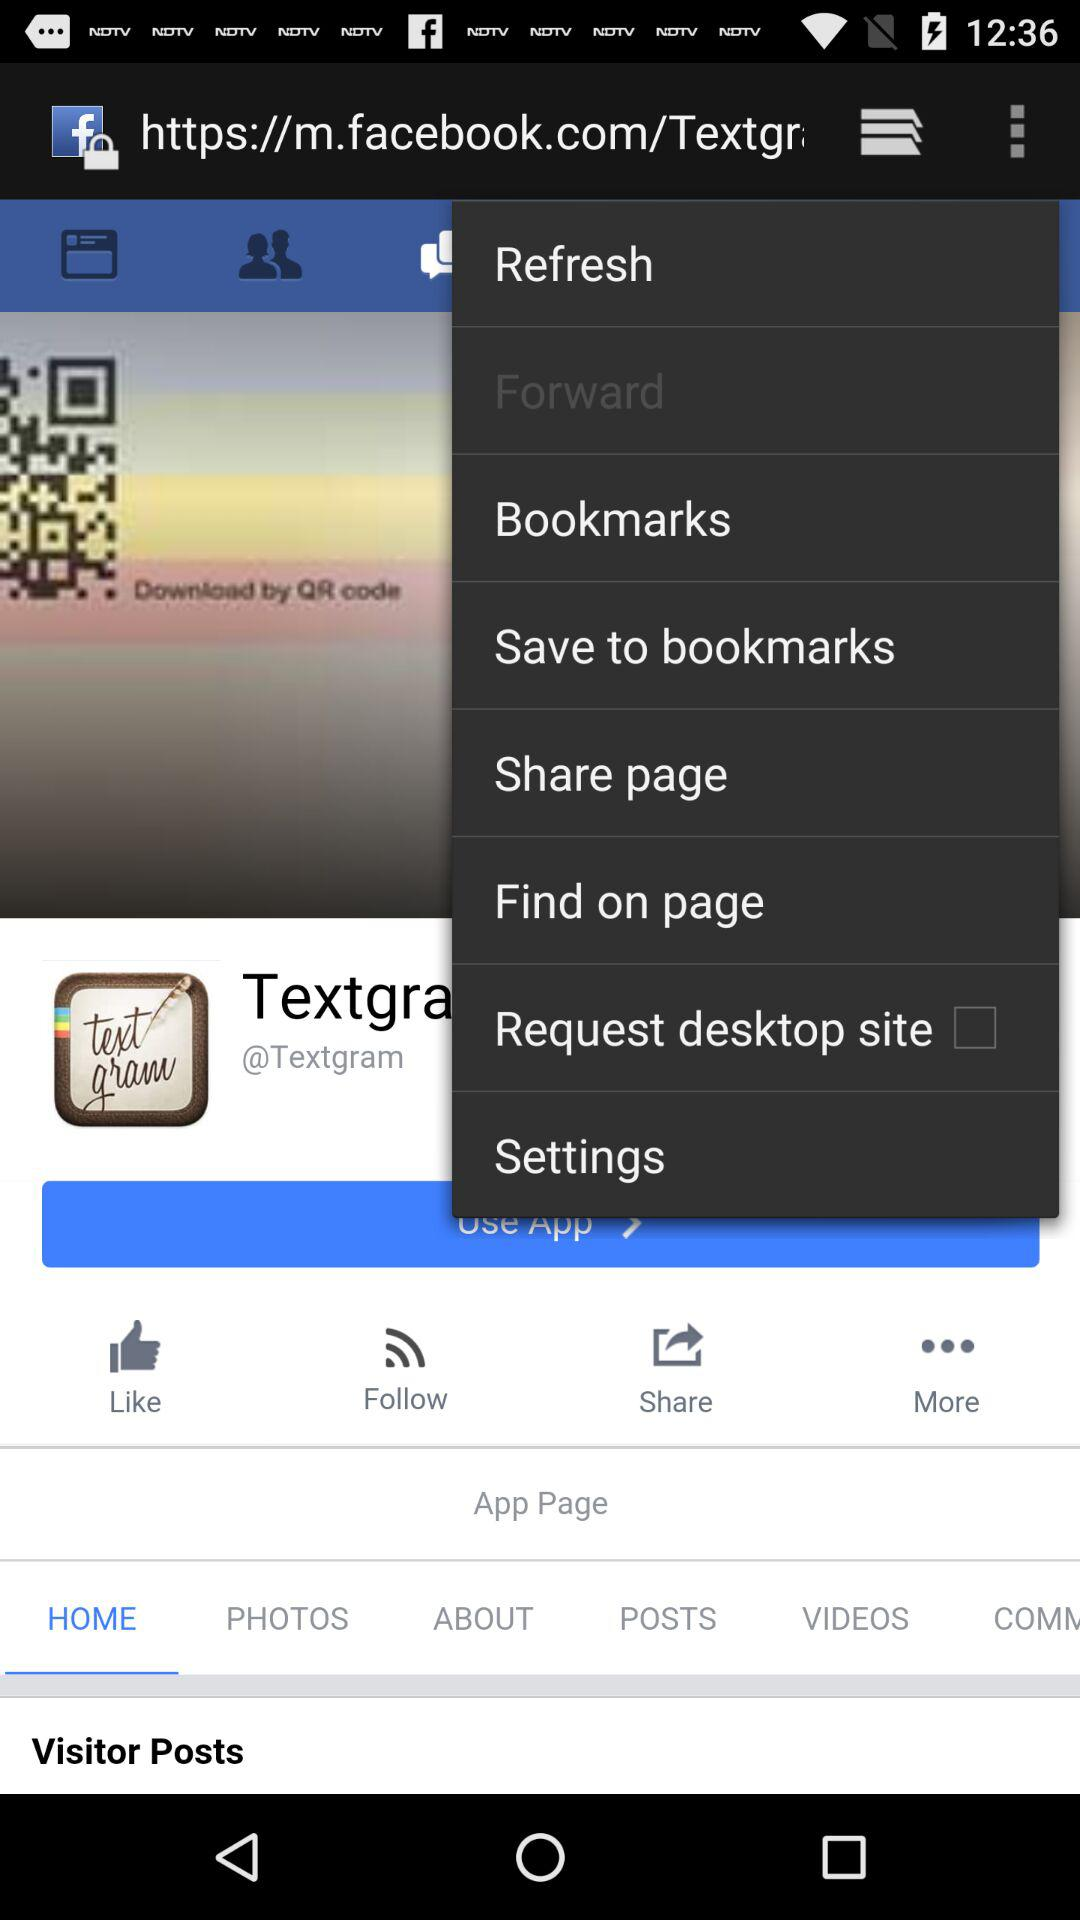What is the application name? The application name is "Textgram". 